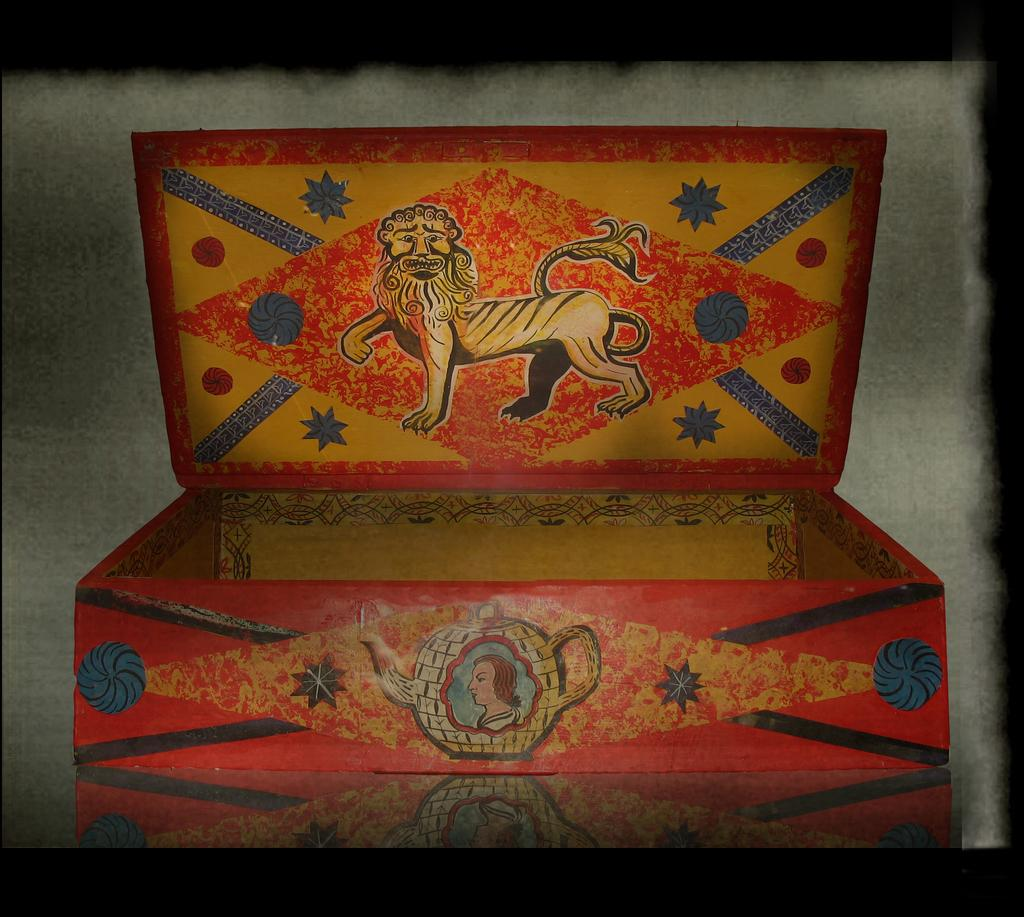What type of object is in the image? There is a colorful wooden box in the image. What is on the wooden box? The wooden box has a painting on it. What does the painting depict? The painting depicts an animal and a person. How many family members can be seen in the painting on the wooden box? There is no family depicted in the painting on the wooden box; it only depicts an animal and a person. What type of building is shown in the painting on the wooden box? There is no building depicted in the painting on the wooden box; it only depicts an animal and a person. 